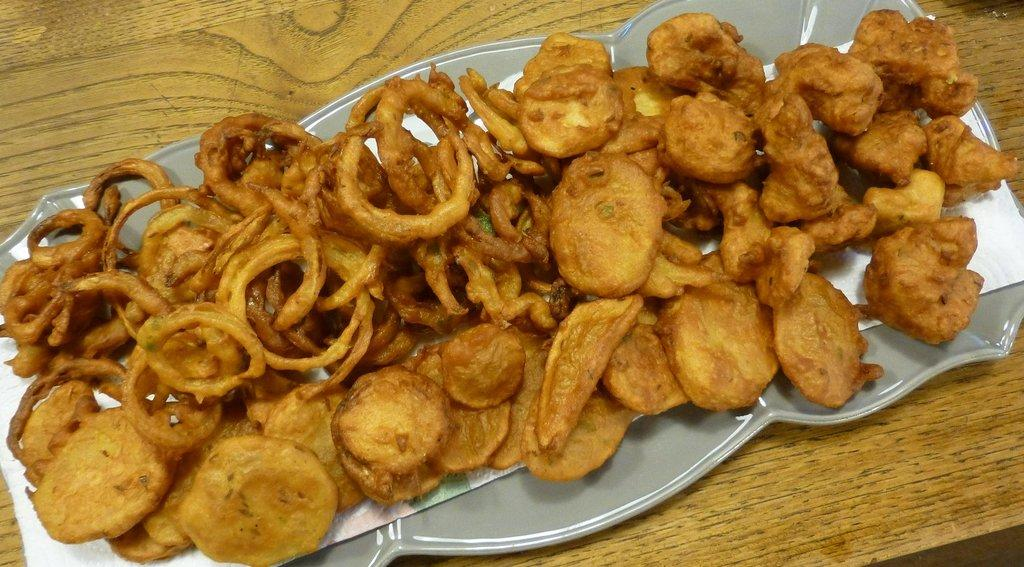What piece of furniture is present in the image? There is a table in the image. What is placed on the table? There is a plate on the table. What is on the plate? The plate contains food. What else is on the table besides the plate? There is paper on the table. Can you hear the drum being played in the image? There is no drum present in the image, so it cannot be heard or played. 